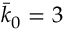Convert formula to latex. <formula><loc_0><loc_0><loc_500><loc_500>\bar { k } _ { 0 } = 3</formula> 